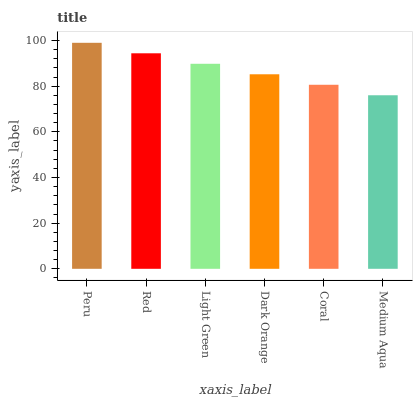Is Medium Aqua the minimum?
Answer yes or no. Yes. Is Peru the maximum?
Answer yes or no. Yes. Is Red the minimum?
Answer yes or no. No. Is Red the maximum?
Answer yes or no. No. Is Peru greater than Red?
Answer yes or no. Yes. Is Red less than Peru?
Answer yes or no. Yes. Is Red greater than Peru?
Answer yes or no. No. Is Peru less than Red?
Answer yes or no. No. Is Light Green the high median?
Answer yes or no. Yes. Is Dark Orange the low median?
Answer yes or no. Yes. Is Coral the high median?
Answer yes or no. No. Is Medium Aqua the low median?
Answer yes or no. No. 